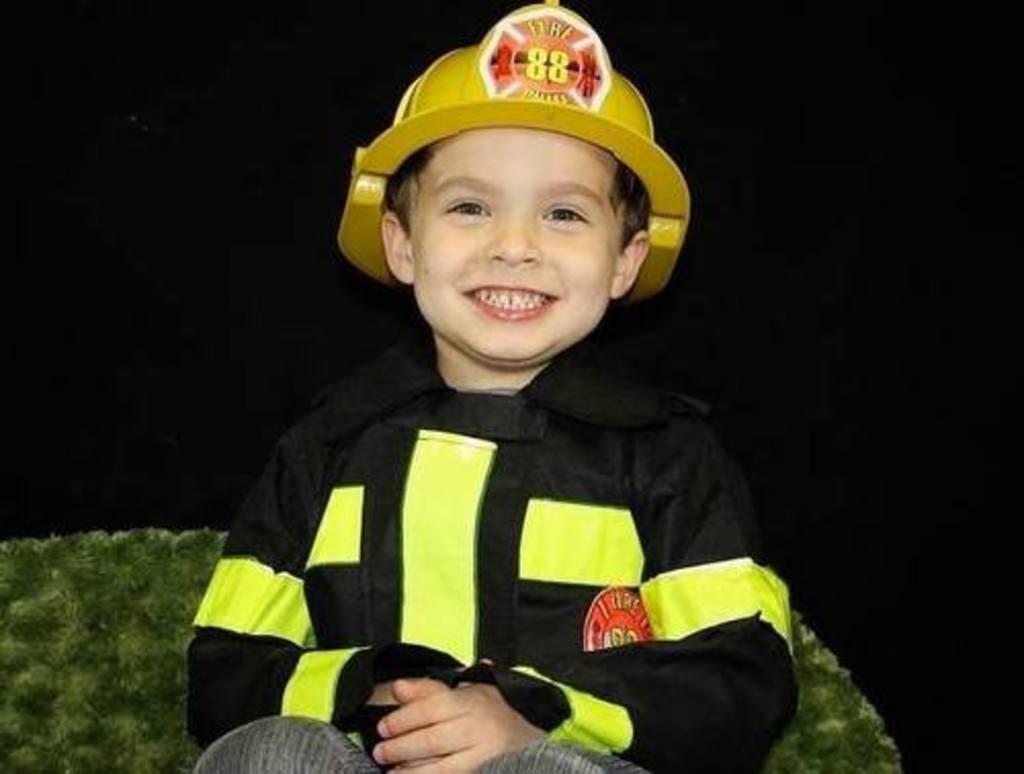Please provide a concise description of this image. In the foreground of the picture there is a boy wearing a firefighter dress, he is wearing a helmet also. The boy is smiling, he is sitting in a couch. The background is dark. 